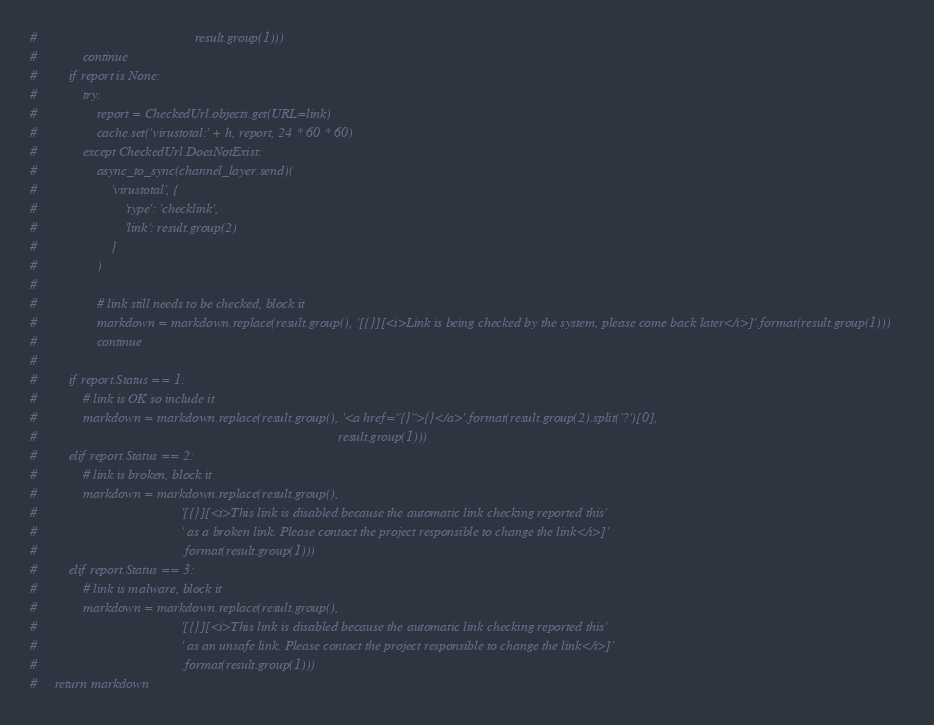<code> <loc_0><loc_0><loc_500><loc_500><_Python_>#                                             result.group(1)))
#             continue
#         if report is None:
#             try:
#                 report = CheckedUrl.objects.get(URL=link)
#                 cache.set('virustotal:' + h, report, 24 * 60 * 60)
#             except CheckedUrl.DoesNotExist:
#                 async_to_sync(channel_layer.send)(
#                     'virustotal', {
#                         'type': 'checklink',
#                         'link': result.group(2)
#                     }
#                 )
#
#                 # link still needs to be checked, block it
#                 markdown = markdown.replace(result.group(), '[{}][<i>Link is being checked by the system, please come back later</i>]'.format(result.group(1)))
#                 continue
#
#         if report.Status == 1:
#             # link is OK so include it
#             markdown = markdown.replace(result.group(), '<a href="{}">{}</a>'.format(result.group(2).split('?')[0],
#                                                                                      result.group(1)))
#         elif report.Status == 2:
#             # link is broken, block it
#             markdown = markdown.replace(result.group(),
#                                         '[{}][<i>This link is disabled because the automatic link checking reported this'
#                                         ' as a broken link. Please contact the project responsible to change the link</i>]'
#                                         .format(result.group(1)))
#         elif report.Status == 3:
#             # link is malware, block it
#             markdown = markdown.replace(result.group(),
#                                         '[{}][<i>This link is disabled because the automatic link checking reported this'
#                                         ' as an unsafe link. Please contact the project responsible to change the link</i>]'
#                                         .format(result.group(1)))
#     return markdown
</code> 